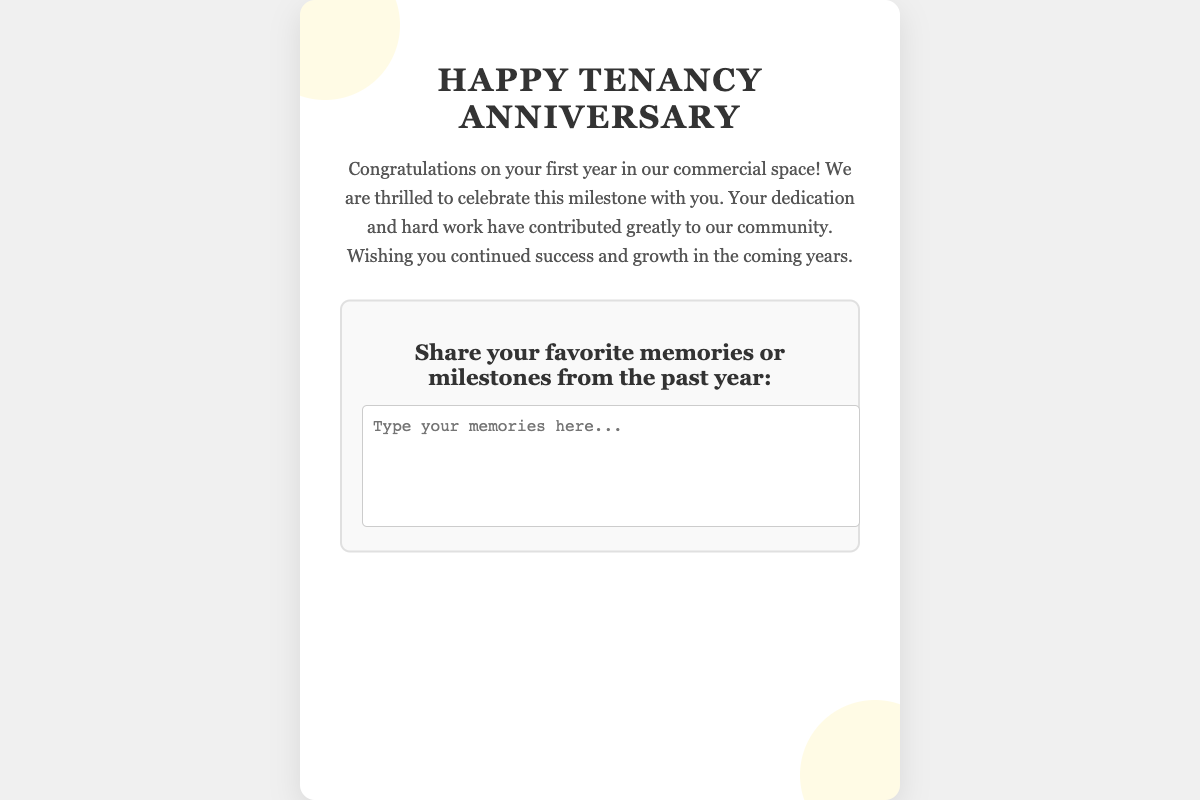What is the title of the card? The title of the card is prominently displayed at the top of the document as a heading.
Answer: Happy Tenancy Anniversary How many years is the anniversary celebrating? The text mentions celebrating the first year in the commercial space as part of the anniversary message.
Answer: One year What colors are used in the card theme? The document describes the theme colors associated with this card as black and gold.
Answer: Black and gold What section is included for sharing personal reflections? There is a section that invites tenants to share memories or milestones they have experienced over the past year.
Answer: Share your favorite memories or milestones from the past year What is written in the greeting message? The greeting message expresses congratulations and well wishes for continued success to the business owner.
Answer: Congratulations on your first year in our commercial space! What type of design elements are used in the card? The document mentions decorative elements such as circular shapes with a specific color and opacity to enhance the card's aesthetic.
Answer: Decoration elements 